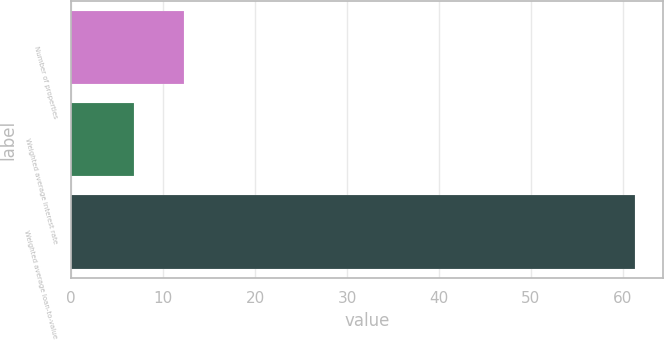<chart> <loc_0><loc_0><loc_500><loc_500><bar_chart><fcel>Number of properties<fcel>Weighted average interest rate<fcel>Weighted average loan-to-value<nl><fcel>12.25<fcel>6.8<fcel>61.3<nl></chart> 